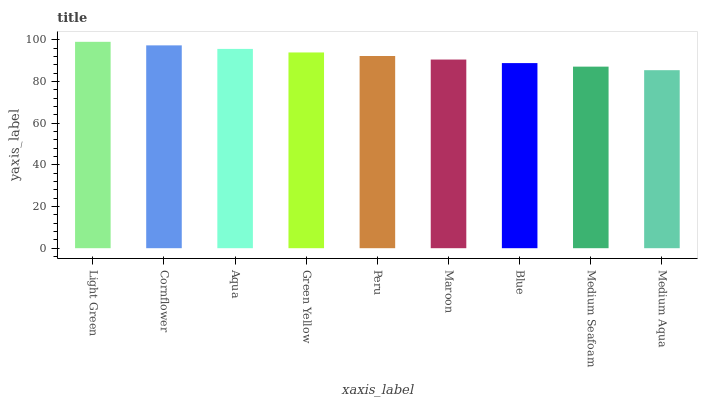Is Medium Aqua the minimum?
Answer yes or no. Yes. Is Light Green the maximum?
Answer yes or no. Yes. Is Cornflower the minimum?
Answer yes or no. No. Is Cornflower the maximum?
Answer yes or no. No. Is Light Green greater than Cornflower?
Answer yes or no. Yes. Is Cornflower less than Light Green?
Answer yes or no. Yes. Is Cornflower greater than Light Green?
Answer yes or no. No. Is Light Green less than Cornflower?
Answer yes or no. No. Is Peru the high median?
Answer yes or no. Yes. Is Peru the low median?
Answer yes or no. Yes. Is Blue the high median?
Answer yes or no. No. Is Cornflower the low median?
Answer yes or no. No. 